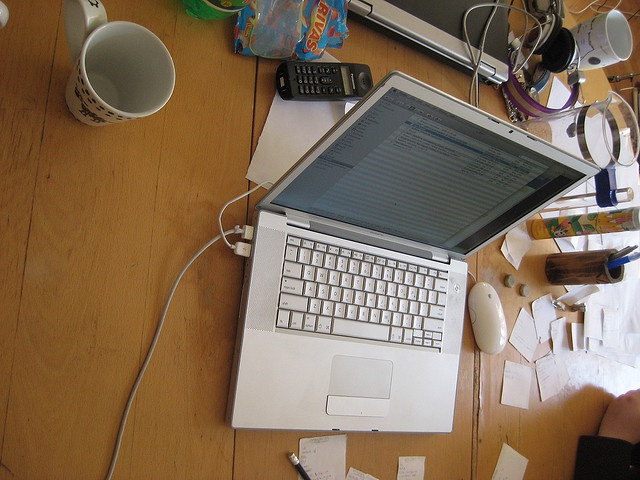Describe the objects in this image and their specific colors. I can see laptop in brown, gray, lightgray, darkgray, and black tones, cup in brown, gray, darkgray, and maroon tones, cup in brown, lightgray, gray, tan, and darkgray tones, people in brown, black, and maroon tones, and cell phone in brown, black, and gray tones in this image. 